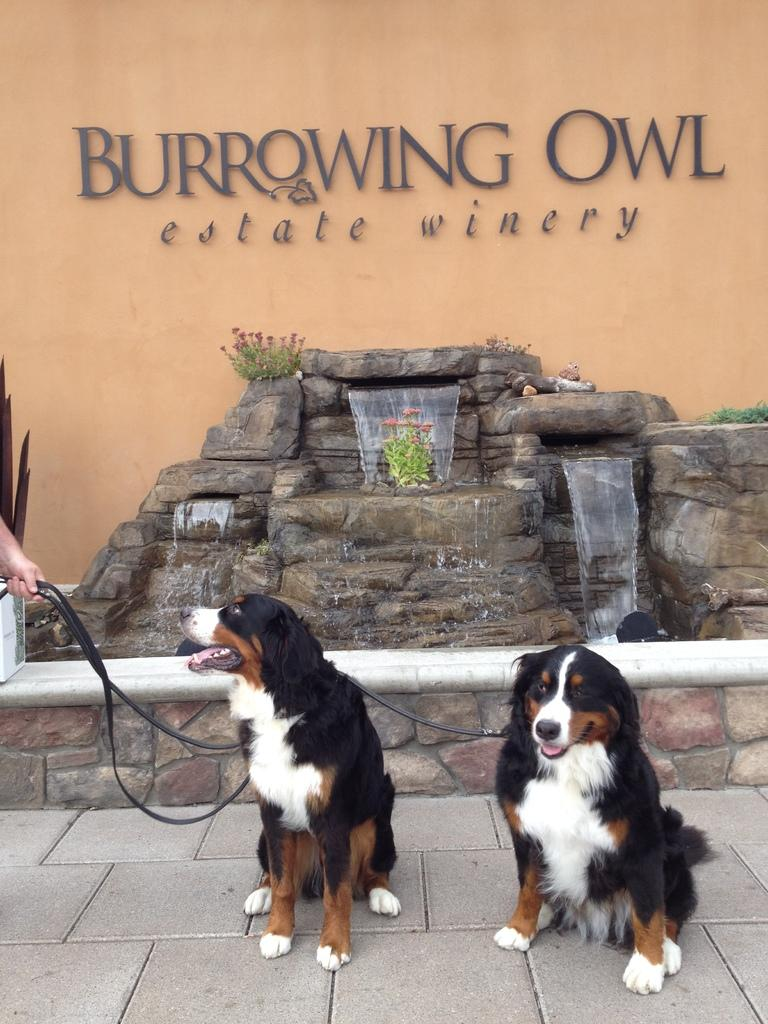How many dogs are in the picture? There are two dogs in the picture. What distinguishing feature do the dogs have? The dogs have belts. Who is holding the dogs in the image? There is a person holding the dogs on the left side of the image. What can be seen in the background of the image? There is a wall in the background of the image. What is written on the wall? There is a name written on the wall. Can you see a swing in the image? No, there is no swing present in the image. What type of ink is used to write the name on the wall? The image does not provide information about the type of ink used to write the name on the wall. 